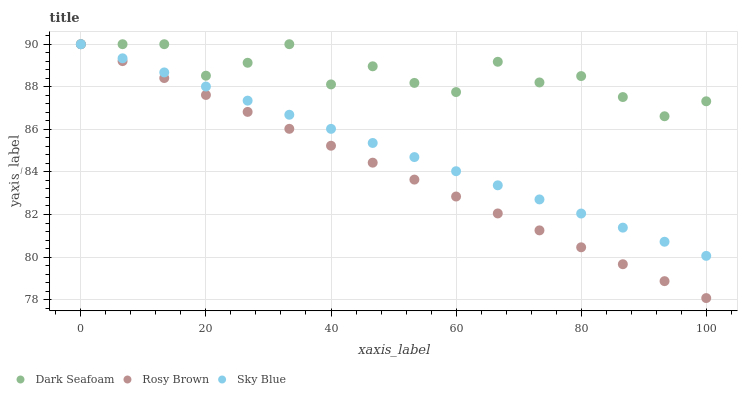Does Rosy Brown have the minimum area under the curve?
Answer yes or no. Yes. Does Dark Seafoam have the maximum area under the curve?
Answer yes or no. Yes. Does Dark Seafoam have the minimum area under the curve?
Answer yes or no. No. Does Rosy Brown have the maximum area under the curve?
Answer yes or no. No. Is Sky Blue the smoothest?
Answer yes or no. Yes. Is Dark Seafoam the roughest?
Answer yes or no. Yes. Is Rosy Brown the smoothest?
Answer yes or no. No. Is Rosy Brown the roughest?
Answer yes or no. No. Does Rosy Brown have the lowest value?
Answer yes or no. Yes. Does Dark Seafoam have the lowest value?
Answer yes or no. No. Does Rosy Brown have the highest value?
Answer yes or no. Yes. Does Dark Seafoam intersect Sky Blue?
Answer yes or no. Yes. Is Dark Seafoam less than Sky Blue?
Answer yes or no. No. Is Dark Seafoam greater than Sky Blue?
Answer yes or no. No. 